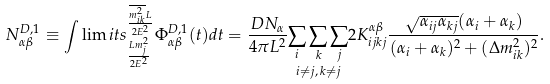<formula> <loc_0><loc_0><loc_500><loc_500>N _ { \alpha \beta } ^ { D , 1 } \equiv \int \lim i t s _ { \frac { L m _ { j } ^ { 2 } } { 2 E ^ { 2 } } } ^ { \frac { \overline { m _ { i k } ^ { 2 } } L } { 2 E ^ { 2 } } } \Phi _ { \alpha \beta } ^ { D , 1 } ( t ) d t = \frac { D N _ { \alpha } } { 4 \pi L ^ { 2 } } \underset { i \neq j , \, k \neq j } { \sum _ { i } \sum _ { k } \sum _ { j } } 2 K _ { i j k j } ^ { \alpha \beta } \frac { \sqrt { \alpha _ { i j } \alpha _ { k j } } ( \alpha _ { i } + \alpha _ { k } ) } { ( \alpha _ { i } + \alpha _ { k } ) ^ { 2 } + ( \Delta m _ { i k } ^ { 2 } ) ^ { 2 } } .</formula> 